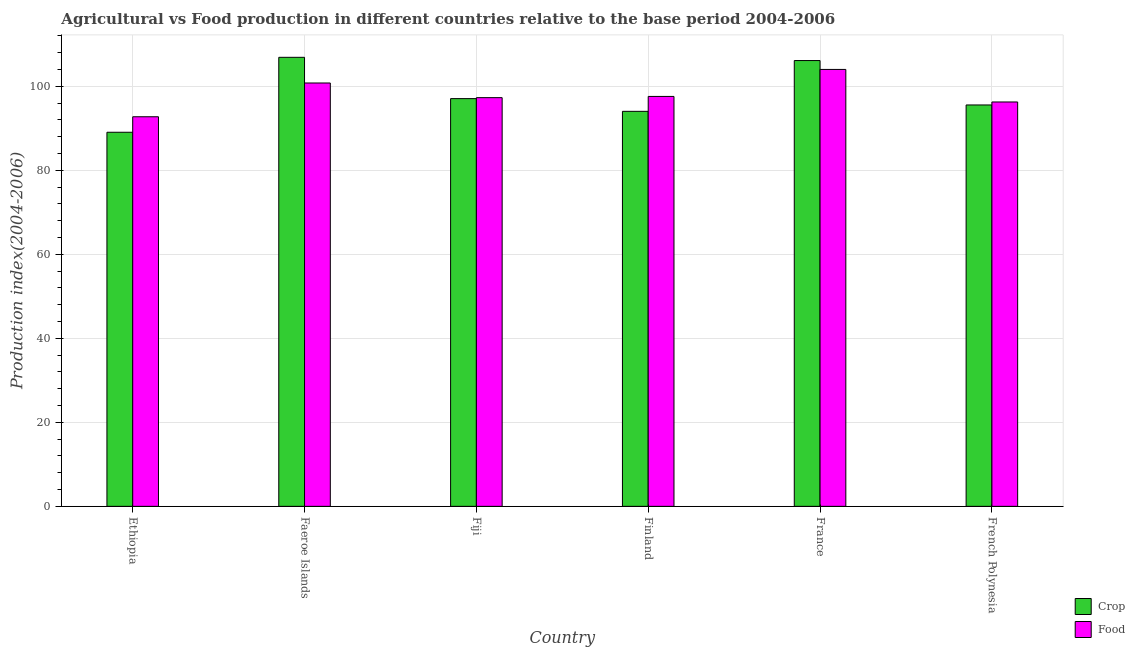How many groups of bars are there?
Provide a succinct answer. 6. Are the number of bars per tick equal to the number of legend labels?
Your answer should be very brief. Yes. Are the number of bars on each tick of the X-axis equal?
Provide a succinct answer. Yes. What is the label of the 2nd group of bars from the left?
Offer a very short reply. Faeroe Islands. What is the food production index in Fiji?
Make the answer very short. 97.3. Across all countries, what is the maximum food production index?
Your answer should be compact. 104.02. Across all countries, what is the minimum crop production index?
Keep it short and to the point. 89.06. In which country was the crop production index minimum?
Offer a terse response. Ethiopia. What is the total crop production index in the graph?
Your response must be concise. 588.76. What is the difference between the food production index in Ethiopia and that in France?
Offer a terse response. -11.27. What is the difference between the crop production index in French Polynesia and the food production index in Ethiopia?
Your response must be concise. 2.81. What is the average crop production index per country?
Give a very brief answer. 98.13. What is the difference between the food production index and crop production index in Faeroe Islands?
Provide a short and direct response. -6.11. What is the ratio of the food production index in Ethiopia to that in France?
Your answer should be compact. 0.89. Is the difference between the crop production index in Fiji and Finland greater than the difference between the food production index in Fiji and Finland?
Your answer should be compact. Yes. What is the difference between the highest and the second highest food production index?
Provide a short and direct response. 3.23. What is the difference between the highest and the lowest food production index?
Keep it short and to the point. 11.27. What does the 2nd bar from the left in French Polynesia represents?
Make the answer very short. Food. What does the 2nd bar from the right in Fiji represents?
Ensure brevity in your answer.  Crop. How many bars are there?
Your answer should be very brief. 12. Are all the bars in the graph horizontal?
Offer a very short reply. No. What is the difference between two consecutive major ticks on the Y-axis?
Provide a succinct answer. 20. How many legend labels are there?
Your response must be concise. 2. How are the legend labels stacked?
Keep it short and to the point. Vertical. What is the title of the graph?
Offer a very short reply. Agricultural vs Food production in different countries relative to the base period 2004-2006. What is the label or title of the Y-axis?
Your response must be concise. Production index(2004-2006). What is the Production index(2004-2006) in Crop in Ethiopia?
Your answer should be very brief. 89.06. What is the Production index(2004-2006) of Food in Ethiopia?
Provide a succinct answer. 92.75. What is the Production index(2004-2006) in Crop in Faeroe Islands?
Ensure brevity in your answer.  106.9. What is the Production index(2004-2006) of Food in Faeroe Islands?
Make the answer very short. 100.79. What is the Production index(2004-2006) in Crop in Fiji?
Provide a succinct answer. 97.07. What is the Production index(2004-2006) of Food in Fiji?
Keep it short and to the point. 97.3. What is the Production index(2004-2006) in Crop in Finland?
Provide a short and direct response. 94.04. What is the Production index(2004-2006) in Food in Finland?
Give a very brief answer. 97.59. What is the Production index(2004-2006) of Crop in France?
Offer a terse response. 106.13. What is the Production index(2004-2006) of Food in France?
Provide a short and direct response. 104.02. What is the Production index(2004-2006) in Crop in French Polynesia?
Your answer should be compact. 95.56. What is the Production index(2004-2006) in Food in French Polynesia?
Ensure brevity in your answer.  96.27. Across all countries, what is the maximum Production index(2004-2006) in Crop?
Provide a short and direct response. 106.9. Across all countries, what is the maximum Production index(2004-2006) in Food?
Ensure brevity in your answer.  104.02. Across all countries, what is the minimum Production index(2004-2006) in Crop?
Offer a very short reply. 89.06. Across all countries, what is the minimum Production index(2004-2006) of Food?
Your answer should be very brief. 92.75. What is the total Production index(2004-2006) of Crop in the graph?
Ensure brevity in your answer.  588.76. What is the total Production index(2004-2006) of Food in the graph?
Provide a short and direct response. 588.72. What is the difference between the Production index(2004-2006) of Crop in Ethiopia and that in Faeroe Islands?
Offer a terse response. -17.84. What is the difference between the Production index(2004-2006) in Food in Ethiopia and that in Faeroe Islands?
Your response must be concise. -8.04. What is the difference between the Production index(2004-2006) of Crop in Ethiopia and that in Fiji?
Your answer should be compact. -8.01. What is the difference between the Production index(2004-2006) in Food in Ethiopia and that in Fiji?
Offer a terse response. -4.55. What is the difference between the Production index(2004-2006) in Crop in Ethiopia and that in Finland?
Provide a short and direct response. -4.98. What is the difference between the Production index(2004-2006) of Food in Ethiopia and that in Finland?
Keep it short and to the point. -4.84. What is the difference between the Production index(2004-2006) in Crop in Ethiopia and that in France?
Your response must be concise. -17.07. What is the difference between the Production index(2004-2006) in Food in Ethiopia and that in France?
Make the answer very short. -11.27. What is the difference between the Production index(2004-2006) in Crop in Ethiopia and that in French Polynesia?
Keep it short and to the point. -6.5. What is the difference between the Production index(2004-2006) of Food in Ethiopia and that in French Polynesia?
Ensure brevity in your answer.  -3.52. What is the difference between the Production index(2004-2006) in Crop in Faeroe Islands and that in Fiji?
Offer a terse response. 9.83. What is the difference between the Production index(2004-2006) in Food in Faeroe Islands and that in Fiji?
Provide a short and direct response. 3.49. What is the difference between the Production index(2004-2006) of Crop in Faeroe Islands and that in Finland?
Offer a very short reply. 12.86. What is the difference between the Production index(2004-2006) in Food in Faeroe Islands and that in Finland?
Provide a short and direct response. 3.2. What is the difference between the Production index(2004-2006) in Crop in Faeroe Islands and that in France?
Ensure brevity in your answer.  0.77. What is the difference between the Production index(2004-2006) in Food in Faeroe Islands and that in France?
Provide a short and direct response. -3.23. What is the difference between the Production index(2004-2006) in Crop in Faeroe Islands and that in French Polynesia?
Keep it short and to the point. 11.34. What is the difference between the Production index(2004-2006) in Food in Faeroe Islands and that in French Polynesia?
Your answer should be very brief. 4.52. What is the difference between the Production index(2004-2006) of Crop in Fiji and that in Finland?
Offer a very short reply. 3.03. What is the difference between the Production index(2004-2006) in Food in Fiji and that in Finland?
Offer a very short reply. -0.29. What is the difference between the Production index(2004-2006) of Crop in Fiji and that in France?
Your answer should be very brief. -9.06. What is the difference between the Production index(2004-2006) of Food in Fiji and that in France?
Your answer should be compact. -6.72. What is the difference between the Production index(2004-2006) in Crop in Fiji and that in French Polynesia?
Offer a very short reply. 1.51. What is the difference between the Production index(2004-2006) in Food in Fiji and that in French Polynesia?
Offer a very short reply. 1.03. What is the difference between the Production index(2004-2006) of Crop in Finland and that in France?
Your response must be concise. -12.09. What is the difference between the Production index(2004-2006) of Food in Finland and that in France?
Keep it short and to the point. -6.43. What is the difference between the Production index(2004-2006) in Crop in Finland and that in French Polynesia?
Keep it short and to the point. -1.52. What is the difference between the Production index(2004-2006) of Food in Finland and that in French Polynesia?
Provide a short and direct response. 1.32. What is the difference between the Production index(2004-2006) of Crop in France and that in French Polynesia?
Ensure brevity in your answer.  10.57. What is the difference between the Production index(2004-2006) of Food in France and that in French Polynesia?
Offer a very short reply. 7.75. What is the difference between the Production index(2004-2006) of Crop in Ethiopia and the Production index(2004-2006) of Food in Faeroe Islands?
Ensure brevity in your answer.  -11.73. What is the difference between the Production index(2004-2006) of Crop in Ethiopia and the Production index(2004-2006) of Food in Fiji?
Make the answer very short. -8.24. What is the difference between the Production index(2004-2006) of Crop in Ethiopia and the Production index(2004-2006) of Food in Finland?
Your answer should be compact. -8.53. What is the difference between the Production index(2004-2006) of Crop in Ethiopia and the Production index(2004-2006) of Food in France?
Provide a short and direct response. -14.96. What is the difference between the Production index(2004-2006) in Crop in Ethiopia and the Production index(2004-2006) in Food in French Polynesia?
Make the answer very short. -7.21. What is the difference between the Production index(2004-2006) of Crop in Faeroe Islands and the Production index(2004-2006) of Food in Fiji?
Ensure brevity in your answer.  9.6. What is the difference between the Production index(2004-2006) of Crop in Faeroe Islands and the Production index(2004-2006) of Food in Finland?
Keep it short and to the point. 9.31. What is the difference between the Production index(2004-2006) of Crop in Faeroe Islands and the Production index(2004-2006) of Food in France?
Provide a short and direct response. 2.88. What is the difference between the Production index(2004-2006) of Crop in Faeroe Islands and the Production index(2004-2006) of Food in French Polynesia?
Offer a very short reply. 10.63. What is the difference between the Production index(2004-2006) of Crop in Fiji and the Production index(2004-2006) of Food in Finland?
Provide a short and direct response. -0.52. What is the difference between the Production index(2004-2006) in Crop in Fiji and the Production index(2004-2006) in Food in France?
Keep it short and to the point. -6.95. What is the difference between the Production index(2004-2006) in Crop in Fiji and the Production index(2004-2006) in Food in French Polynesia?
Provide a succinct answer. 0.8. What is the difference between the Production index(2004-2006) in Crop in Finland and the Production index(2004-2006) in Food in France?
Give a very brief answer. -9.98. What is the difference between the Production index(2004-2006) in Crop in Finland and the Production index(2004-2006) in Food in French Polynesia?
Your answer should be very brief. -2.23. What is the difference between the Production index(2004-2006) in Crop in France and the Production index(2004-2006) in Food in French Polynesia?
Your response must be concise. 9.86. What is the average Production index(2004-2006) of Crop per country?
Your answer should be compact. 98.13. What is the average Production index(2004-2006) of Food per country?
Provide a succinct answer. 98.12. What is the difference between the Production index(2004-2006) in Crop and Production index(2004-2006) in Food in Ethiopia?
Keep it short and to the point. -3.69. What is the difference between the Production index(2004-2006) in Crop and Production index(2004-2006) in Food in Faeroe Islands?
Make the answer very short. 6.11. What is the difference between the Production index(2004-2006) in Crop and Production index(2004-2006) in Food in Fiji?
Provide a short and direct response. -0.23. What is the difference between the Production index(2004-2006) of Crop and Production index(2004-2006) of Food in Finland?
Your response must be concise. -3.55. What is the difference between the Production index(2004-2006) of Crop and Production index(2004-2006) of Food in France?
Your answer should be compact. 2.11. What is the difference between the Production index(2004-2006) of Crop and Production index(2004-2006) of Food in French Polynesia?
Provide a short and direct response. -0.71. What is the ratio of the Production index(2004-2006) of Crop in Ethiopia to that in Faeroe Islands?
Offer a very short reply. 0.83. What is the ratio of the Production index(2004-2006) in Food in Ethiopia to that in Faeroe Islands?
Provide a short and direct response. 0.92. What is the ratio of the Production index(2004-2006) in Crop in Ethiopia to that in Fiji?
Make the answer very short. 0.92. What is the ratio of the Production index(2004-2006) in Food in Ethiopia to that in Fiji?
Provide a short and direct response. 0.95. What is the ratio of the Production index(2004-2006) of Crop in Ethiopia to that in Finland?
Your response must be concise. 0.95. What is the ratio of the Production index(2004-2006) in Food in Ethiopia to that in Finland?
Your answer should be very brief. 0.95. What is the ratio of the Production index(2004-2006) of Crop in Ethiopia to that in France?
Make the answer very short. 0.84. What is the ratio of the Production index(2004-2006) in Food in Ethiopia to that in France?
Your response must be concise. 0.89. What is the ratio of the Production index(2004-2006) in Crop in Ethiopia to that in French Polynesia?
Make the answer very short. 0.93. What is the ratio of the Production index(2004-2006) in Food in Ethiopia to that in French Polynesia?
Offer a very short reply. 0.96. What is the ratio of the Production index(2004-2006) in Crop in Faeroe Islands to that in Fiji?
Your answer should be very brief. 1.1. What is the ratio of the Production index(2004-2006) of Food in Faeroe Islands to that in Fiji?
Make the answer very short. 1.04. What is the ratio of the Production index(2004-2006) of Crop in Faeroe Islands to that in Finland?
Ensure brevity in your answer.  1.14. What is the ratio of the Production index(2004-2006) in Food in Faeroe Islands to that in Finland?
Your answer should be very brief. 1.03. What is the ratio of the Production index(2004-2006) of Crop in Faeroe Islands to that in France?
Give a very brief answer. 1.01. What is the ratio of the Production index(2004-2006) of Food in Faeroe Islands to that in France?
Provide a short and direct response. 0.97. What is the ratio of the Production index(2004-2006) of Crop in Faeroe Islands to that in French Polynesia?
Your answer should be very brief. 1.12. What is the ratio of the Production index(2004-2006) in Food in Faeroe Islands to that in French Polynesia?
Ensure brevity in your answer.  1.05. What is the ratio of the Production index(2004-2006) in Crop in Fiji to that in Finland?
Offer a terse response. 1.03. What is the ratio of the Production index(2004-2006) in Food in Fiji to that in Finland?
Ensure brevity in your answer.  1. What is the ratio of the Production index(2004-2006) of Crop in Fiji to that in France?
Provide a succinct answer. 0.91. What is the ratio of the Production index(2004-2006) of Food in Fiji to that in France?
Make the answer very short. 0.94. What is the ratio of the Production index(2004-2006) of Crop in Fiji to that in French Polynesia?
Your answer should be very brief. 1.02. What is the ratio of the Production index(2004-2006) of Food in Fiji to that in French Polynesia?
Ensure brevity in your answer.  1.01. What is the ratio of the Production index(2004-2006) of Crop in Finland to that in France?
Ensure brevity in your answer.  0.89. What is the ratio of the Production index(2004-2006) in Food in Finland to that in France?
Offer a terse response. 0.94. What is the ratio of the Production index(2004-2006) of Crop in Finland to that in French Polynesia?
Provide a short and direct response. 0.98. What is the ratio of the Production index(2004-2006) in Food in Finland to that in French Polynesia?
Your answer should be very brief. 1.01. What is the ratio of the Production index(2004-2006) of Crop in France to that in French Polynesia?
Offer a terse response. 1.11. What is the ratio of the Production index(2004-2006) of Food in France to that in French Polynesia?
Ensure brevity in your answer.  1.08. What is the difference between the highest and the second highest Production index(2004-2006) of Crop?
Keep it short and to the point. 0.77. What is the difference between the highest and the second highest Production index(2004-2006) in Food?
Keep it short and to the point. 3.23. What is the difference between the highest and the lowest Production index(2004-2006) of Crop?
Provide a short and direct response. 17.84. What is the difference between the highest and the lowest Production index(2004-2006) in Food?
Offer a terse response. 11.27. 